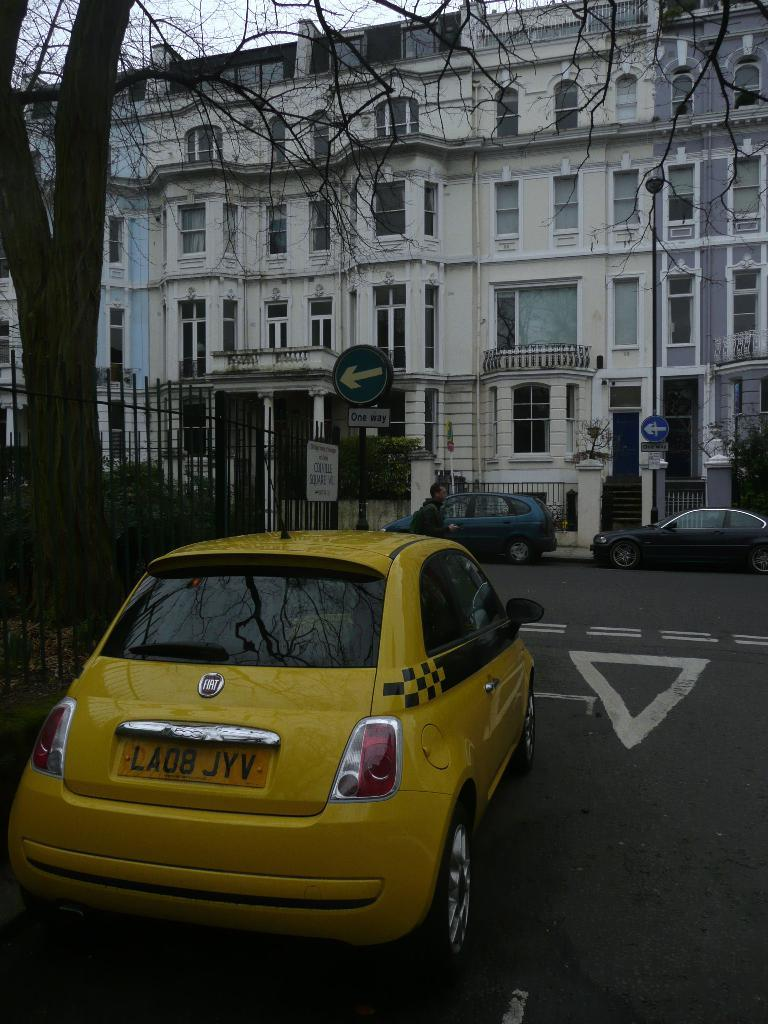<image>
Provide a brief description of the given image. A taxi that has the label LA08 JYV on its tag 